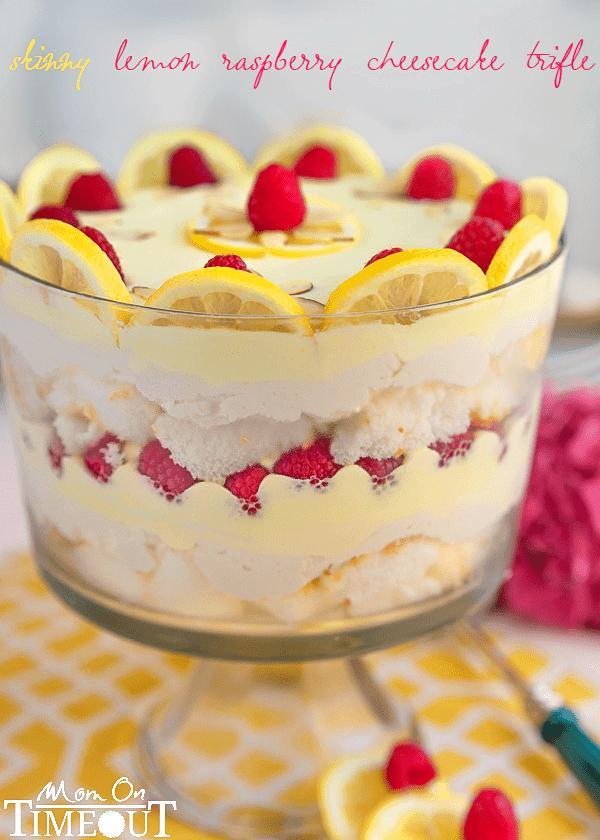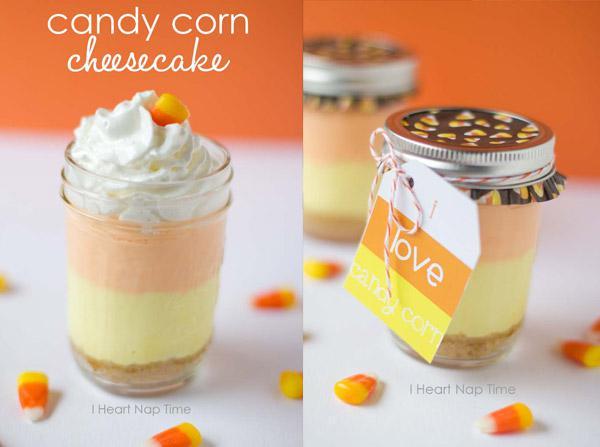The first image is the image on the left, the second image is the image on the right. Analyze the images presented: Is the assertion "At least one image shows individual servings of layered dessert in non-footed glasses garnished with raspberries." valid? Answer yes or no. No. The first image is the image on the left, the second image is the image on the right. For the images shown, is this caption "There are lemon slices on top of a trifle in one of the images." true? Answer yes or no. Yes. 